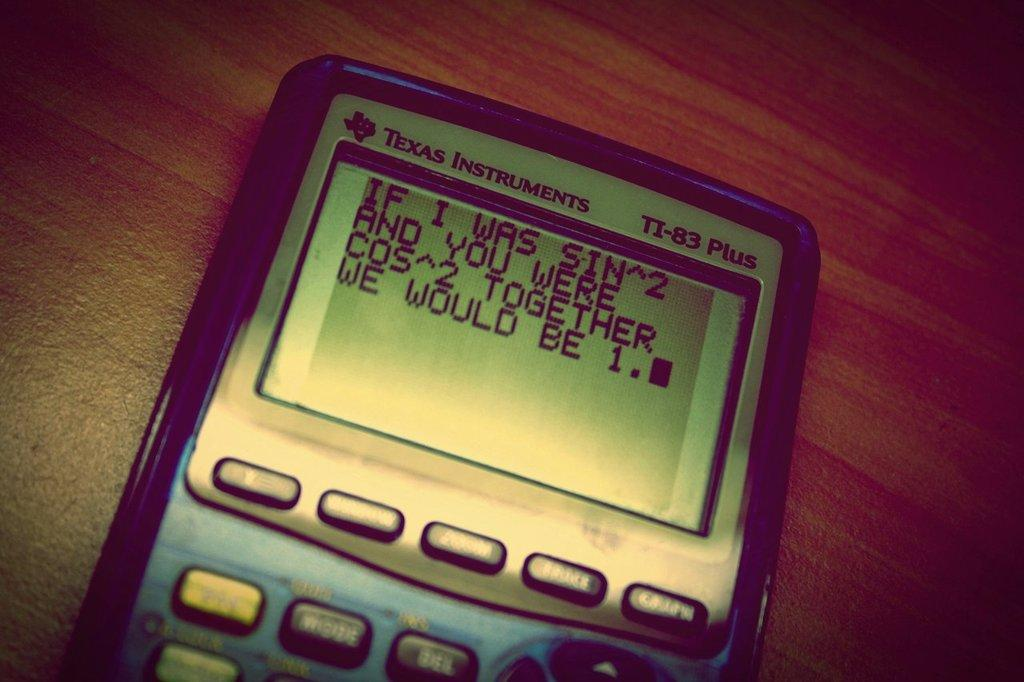<image>
Offer a succinct explanation of the picture presented. A message on a calculator screen end with the words we would be 1. 